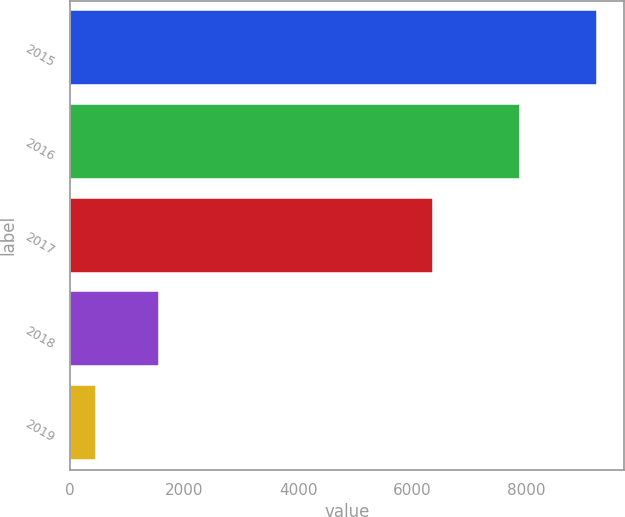Convert chart. <chart><loc_0><loc_0><loc_500><loc_500><bar_chart><fcel>2015<fcel>2016<fcel>2017<fcel>2018<fcel>2019<nl><fcel>9247<fcel>7888<fcel>6370<fcel>1556<fcel>459<nl></chart> 